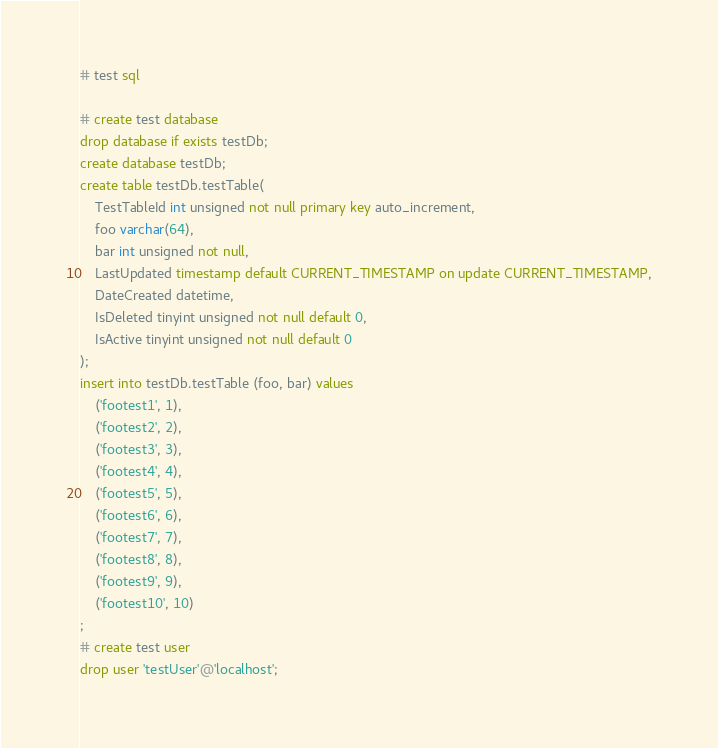<code> <loc_0><loc_0><loc_500><loc_500><_SQL_># test sql

# create test database
drop database if exists testDb; 
create database testDb;
create table testDb.testTable(
	TestTableId int unsigned not null primary key auto_increment, 
	foo varchar(64), 
	bar int unsigned not null,
	LastUpdated timestamp default CURRENT_TIMESTAMP on update CURRENT_TIMESTAMP,
	DateCreated datetime, 
	IsDeleted tinyint unsigned not null default 0, 
	IsActive tinyint unsigned not null default 0
);
insert into testDb.testTable (foo, bar) values 
	('footest1', 1), 
	('footest2', 2), 
	('footest3', 3), 
	('footest4', 4), 
	('footest5', 5), 
	('footest6', 6), 
	('footest7', 7), 
	('footest8', 8), 
	('footest9', 9), 
	('footest10', 10)
;
# create test user 
drop user 'testUser'@'localhost'; </code> 